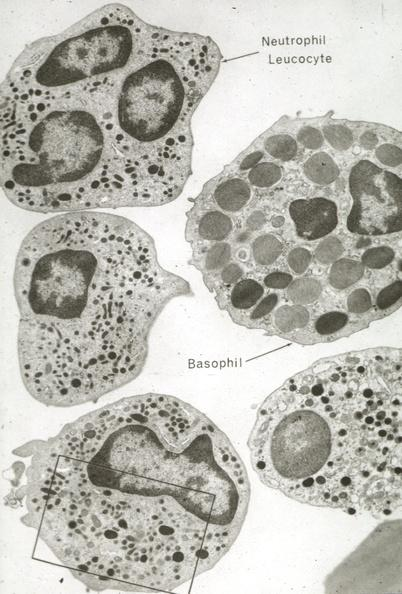s blood present?
Answer the question using a single word or phrase. Yes 